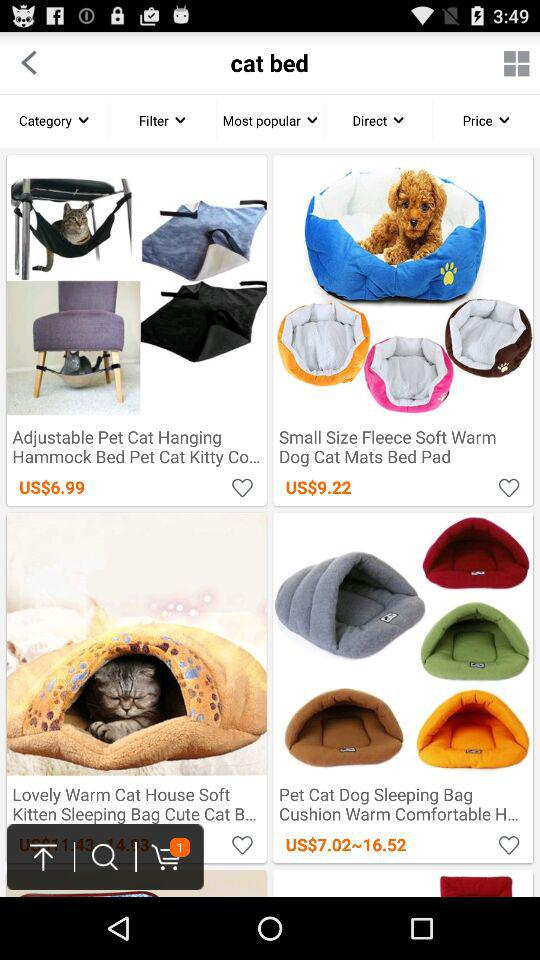What is the number of items in the cart? The number of items in the cart is 1. 